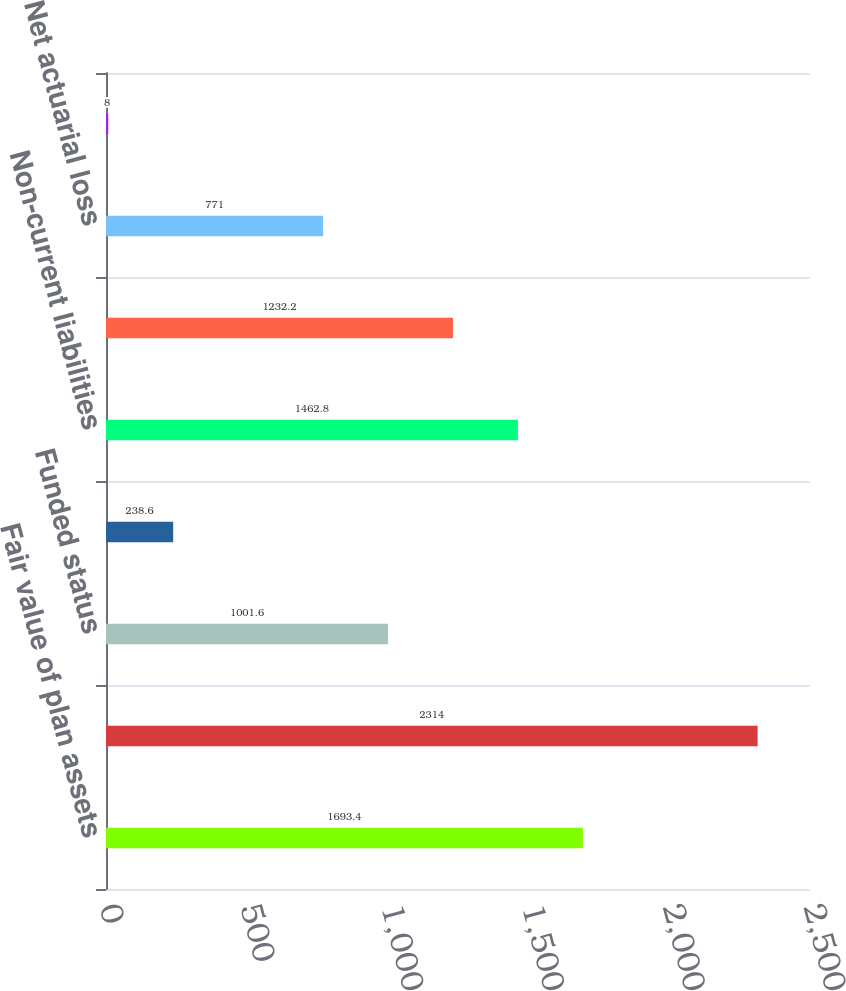<chart> <loc_0><loc_0><loc_500><loc_500><bar_chart><fcel>Fair value of plan assets<fcel>Benefit obligations<fcel>Funded status<fcel>Current liabilities<fcel>Non-current liabilities<fcel>Total<fcel>Net actuarial loss<fcel>Prior service cost (credit)<nl><fcel>1693.4<fcel>2314<fcel>1001.6<fcel>238.6<fcel>1462.8<fcel>1232.2<fcel>771<fcel>8<nl></chart> 